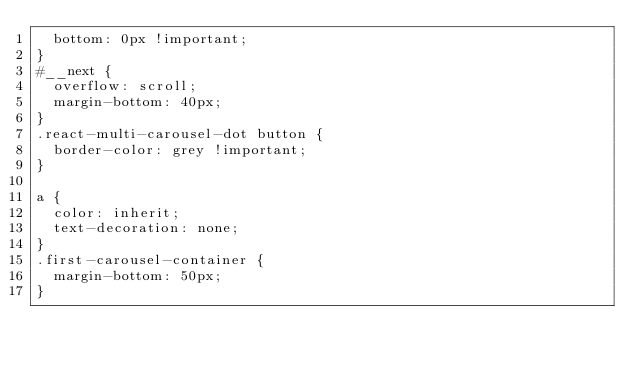Convert code to text. <code><loc_0><loc_0><loc_500><loc_500><_CSS_>  bottom: 0px !important;
}
#__next {
  overflow: scroll;
  margin-bottom: 40px;
}
.react-multi-carousel-dot button {
  border-color: grey !important;
}

a {
  color: inherit;
  text-decoration: none;
}
.first-carousel-container {
  margin-bottom: 50px;
}
</code> 